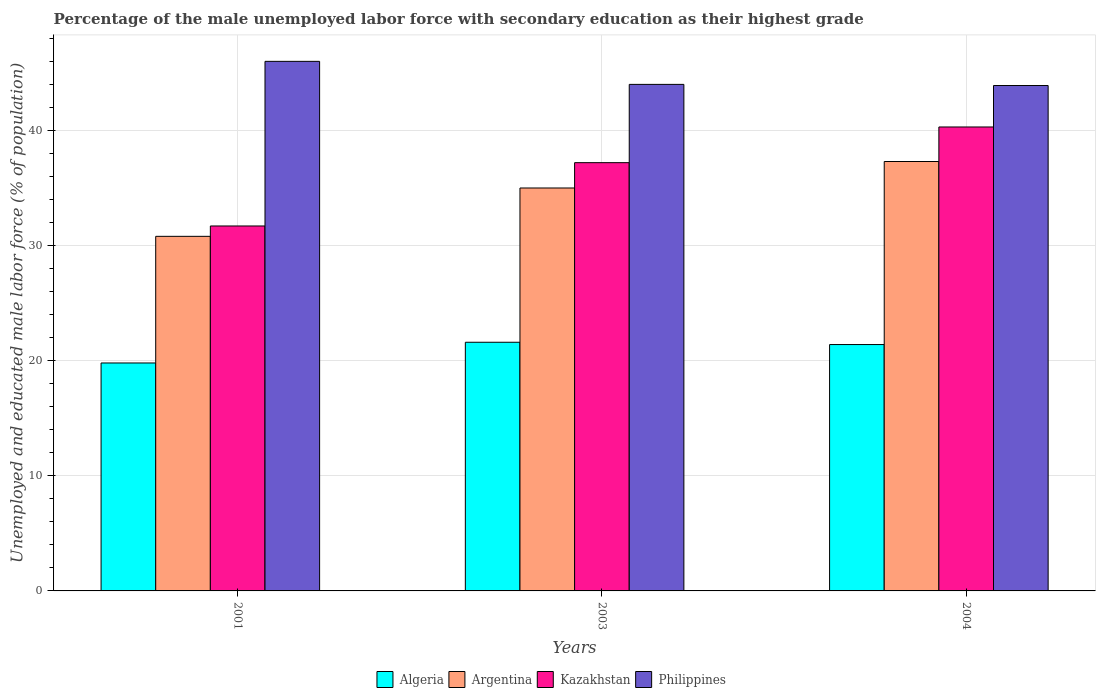How many different coloured bars are there?
Make the answer very short. 4. How many groups of bars are there?
Give a very brief answer. 3. Are the number of bars on each tick of the X-axis equal?
Your answer should be compact. Yes. How many bars are there on the 1st tick from the left?
Your response must be concise. 4. How many bars are there on the 3rd tick from the right?
Offer a terse response. 4. What is the percentage of the unemployed male labor force with secondary education in Kazakhstan in 2004?
Give a very brief answer. 40.3. Across all years, what is the maximum percentage of the unemployed male labor force with secondary education in Philippines?
Your answer should be compact. 46. Across all years, what is the minimum percentage of the unemployed male labor force with secondary education in Philippines?
Provide a succinct answer. 43.9. In which year was the percentage of the unemployed male labor force with secondary education in Kazakhstan maximum?
Offer a very short reply. 2004. What is the total percentage of the unemployed male labor force with secondary education in Kazakhstan in the graph?
Ensure brevity in your answer.  109.2. What is the difference between the percentage of the unemployed male labor force with secondary education in Argentina in 2001 and that in 2003?
Your response must be concise. -4.2. What is the difference between the percentage of the unemployed male labor force with secondary education in Kazakhstan in 2003 and the percentage of the unemployed male labor force with secondary education in Algeria in 2004?
Keep it short and to the point. 15.8. What is the average percentage of the unemployed male labor force with secondary education in Algeria per year?
Keep it short and to the point. 20.93. In the year 2004, what is the difference between the percentage of the unemployed male labor force with secondary education in Algeria and percentage of the unemployed male labor force with secondary education in Philippines?
Your answer should be very brief. -22.5. In how many years, is the percentage of the unemployed male labor force with secondary education in Philippines greater than 20 %?
Give a very brief answer. 3. What is the ratio of the percentage of the unemployed male labor force with secondary education in Kazakhstan in 2003 to that in 2004?
Keep it short and to the point. 0.92. Is the percentage of the unemployed male labor force with secondary education in Philippines in 2003 less than that in 2004?
Provide a succinct answer. No. Is the difference between the percentage of the unemployed male labor force with secondary education in Algeria in 2001 and 2003 greater than the difference between the percentage of the unemployed male labor force with secondary education in Philippines in 2001 and 2003?
Your answer should be very brief. No. What is the difference between the highest and the second highest percentage of the unemployed male labor force with secondary education in Kazakhstan?
Offer a very short reply. 3.1. What is the difference between the highest and the lowest percentage of the unemployed male labor force with secondary education in Philippines?
Keep it short and to the point. 2.1. Is it the case that in every year, the sum of the percentage of the unemployed male labor force with secondary education in Philippines and percentage of the unemployed male labor force with secondary education in Kazakhstan is greater than the sum of percentage of the unemployed male labor force with secondary education in Argentina and percentage of the unemployed male labor force with secondary education in Algeria?
Provide a short and direct response. No. What does the 3rd bar from the left in 2003 represents?
Your answer should be very brief. Kazakhstan. What does the 4th bar from the right in 2001 represents?
Your answer should be compact. Algeria. Is it the case that in every year, the sum of the percentage of the unemployed male labor force with secondary education in Argentina and percentage of the unemployed male labor force with secondary education in Algeria is greater than the percentage of the unemployed male labor force with secondary education in Philippines?
Provide a succinct answer. Yes. What is the difference between two consecutive major ticks on the Y-axis?
Your response must be concise. 10. Are the values on the major ticks of Y-axis written in scientific E-notation?
Keep it short and to the point. No. Does the graph contain any zero values?
Your response must be concise. No. What is the title of the graph?
Provide a succinct answer. Percentage of the male unemployed labor force with secondary education as their highest grade. Does "Lesotho" appear as one of the legend labels in the graph?
Make the answer very short. No. What is the label or title of the Y-axis?
Your answer should be very brief. Unemployed and educated male labor force (% of population). What is the Unemployed and educated male labor force (% of population) in Algeria in 2001?
Provide a short and direct response. 19.8. What is the Unemployed and educated male labor force (% of population) of Argentina in 2001?
Provide a short and direct response. 30.8. What is the Unemployed and educated male labor force (% of population) in Kazakhstan in 2001?
Your answer should be very brief. 31.7. What is the Unemployed and educated male labor force (% of population) in Philippines in 2001?
Give a very brief answer. 46. What is the Unemployed and educated male labor force (% of population) in Algeria in 2003?
Your answer should be compact. 21.6. What is the Unemployed and educated male labor force (% of population) of Kazakhstan in 2003?
Offer a very short reply. 37.2. What is the Unemployed and educated male labor force (% of population) in Algeria in 2004?
Offer a very short reply. 21.4. What is the Unemployed and educated male labor force (% of population) of Argentina in 2004?
Provide a succinct answer. 37.3. What is the Unemployed and educated male labor force (% of population) in Kazakhstan in 2004?
Keep it short and to the point. 40.3. What is the Unemployed and educated male labor force (% of population) of Philippines in 2004?
Make the answer very short. 43.9. Across all years, what is the maximum Unemployed and educated male labor force (% of population) in Algeria?
Your answer should be compact. 21.6. Across all years, what is the maximum Unemployed and educated male labor force (% of population) of Argentina?
Make the answer very short. 37.3. Across all years, what is the maximum Unemployed and educated male labor force (% of population) in Kazakhstan?
Give a very brief answer. 40.3. Across all years, what is the minimum Unemployed and educated male labor force (% of population) in Algeria?
Your response must be concise. 19.8. Across all years, what is the minimum Unemployed and educated male labor force (% of population) in Argentina?
Offer a terse response. 30.8. Across all years, what is the minimum Unemployed and educated male labor force (% of population) of Kazakhstan?
Make the answer very short. 31.7. Across all years, what is the minimum Unemployed and educated male labor force (% of population) of Philippines?
Your answer should be very brief. 43.9. What is the total Unemployed and educated male labor force (% of population) in Algeria in the graph?
Keep it short and to the point. 62.8. What is the total Unemployed and educated male labor force (% of population) of Argentina in the graph?
Your answer should be compact. 103.1. What is the total Unemployed and educated male labor force (% of population) of Kazakhstan in the graph?
Provide a succinct answer. 109.2. What is the total Unemployed and educated male labor force (% of population) of Philippines in the graph?
Provide a short and direct response. 133.9. What is the difference between the Unemployed and educated male labor force (% of population) of Algeria in 2001 and that in 2003?
Offer a very short reply. -1.8. What is the difference between the Unemployed and educated male labor force (% of population) in Argentina in 2001 and that in 2003?
Offer a very short reply. -4.2. What is the difference between the Unemployed and educated male labor force (% of population) in Philippines in 2001 and that in 2003?
Make the answer very short. 2. What is the difference between the Unemployed and educated male labor force (% of population) in Argentina in 2001 and that in 2004?
Offer a very short reply. -6.5. What is the difference between the Unemployed and educated male labor force (% of population) in Kazakhstan in 2001 and that in 2004?
Provide a short and direct response. -8.6. What is the difference between the Unemployed and educated male labor force (% of population) in Algeria in 2003 and that in 2004?
Give a very brief answer. 0.2. What is the difference between the Unemployed and educated male labor force (% of population) in Philippines in 2003 and that in 2004?
Your response must be concise. 0.1. What is the difference between the Unemployed and educated male labor force (% of population) in Algeria in 2001 and the Unemployed and educated male labor force (% of population) in Argentina in 2003?
Give a very brief answer. -15.2. What is the difference between the Unemployed and educated male labor force (% of population) of Algeria in 2001 and the Unemployed and educated male labor force (% of population) of Kazakhstan in 2003?
Ensure brevity in your answer.  -17.4. What is the difference between the Unemployed and educated male labor force (% of population) of Algeria in 2001 and the Unemployed and educated male labor force (% of population) of Philippines in 2003?
Keep it short and to the point. -24.2. What is the difference between the Unemployed and educated male labor force (% of population) of Algeria in 2001 and the Unemployed and educated male labor force (% of population) of Argentina in 2004?
Keep it short and to the point. -17.5. What is the difference between the Unemployed and educated male labor force (% of population) of Algeria in 2001 and the Unemployed and educated male labor force (% of population) of Kazakhstan in 2004?
Offer a very short reply. -20.5. What is the difference between the Unemployed and educated male labor force (% of population) of Algeria in 2001 and the Unemployed and educated male labor force (% of population) of Philippines in 2004?
Give a very brief answer. -24.1. What is the difference between the Unemployed and educated male labor force (% of population) in Argentina in 2001 and the Unemployed and educated male labor force (% of population) in Kazakhstan in 2004?
Your answer should be compact. -9.5. What is the difference between the Unemployed and educated male labor force (% of population) in Algeria in 2003 and the Unemployed and educated male labor force (% of population) in Argentina in 2004?
Your response must be concise. -15.7. What is the difference between the Unemployed and educated male labor force (% of population) of Algeria in 2003 and the Unemployed and educated male labor force (% of population) of Kazakhstan in 2004?
Your answer should be very brief. -18.7. What is the difference between the Unemployed and educated male labor force (% of population) of Algeria in 2003 and the Unemployed and educated male labor force (% of population) of Philippines in 2004?
Offer a terse response. -22.3. What is the difference between the Unemployed and educated male labor force (% of population) in Argentina in 2003 and the Unemployed and educated male labor force (% of population) in Kazakhstan in 2004?
Make the answer very short. -5.3. What is the difference between the Unemployed and educated male labor force (% of population) of Argentina in 2003 and the Unemployed and educated male labor force (% of population) of Philippines in 2004?
Provide a short and direct response. -8.9. What is the average Unemployed and educated male labor force (% of population) of Algeria per year?
Your answer should be compact. 20.93. What is the average Unemployed and educated male labor force (% of population) of Argentina per year?
Offer a very short reply. 34.37. What is the average Unemployed and educated male labor force (% of population) of Kazakhstan per year?
Give a very brief answer. 36.4. What is the average Unemployed and educated male labor force (% of population) of Philippines per year?
Your response must be concise. 44.63. In the year 2001, what is the difference between the Unemployed and educated male labor force (% of population) of Algeria and Unemployed and educated male labor force (% of population) of Kazakhstan?
Provide a short and direct response. -11.9. In the year 2001, what is the difference between the Unemployed and educated male labor force (% of population) of Algeria and Unemployed and educated male labor force (% of population) of Philippines?
Offer a terse response. -26.2. In the year 2001, what is the difference between the Unemployed and educated male labor force (% of population) in Argentina and Unemployed and educated male labor force (% of population) in Kazakhstan?
Your response must be concise. -0.9. In the year 2001, what is the difference between the Unemployed and educated male labor force (% of population) in Argentina and Unemployed and educated male labor force (% of population) in Philippines?
Offer a very short reply. -15.2. In the year 2001, what is the difference between the Unemployed and educated male labor force (% of population) of Kazakhstan and Unemployed and educated male labor force (% of population) of Philippines?
Your answer should be very brief. -14.3. In the year 2003, what is the difference between the Unemployed and educated male labor force (% of population) in Algeria and Unemployed and educated male labor force (% of population) in Argentina?
Provide a succinct answer. -13.4. In the year 2003, what is the difference between the Unemployed and educated male labor force (% of population) of Algeria and Unemployed and educated male labor force (% of population) of Kazakhstan?
Keep it short and to the point. -15.6. In the year 2003, what is the difference between the Unemployed and educated male labor force (% of population) in Algeria and Unemployed and educated male labor force (% of population) in Philippines?
Your answer should be compact. -22.4. In the year 2004, what is the difference between the Unemployed and educated male labor force (% of population) in Algeria and Unemployed and educated male labor force (% of population) in Argentina?
Keep it short and to the point. -15.9. In the year 2004, what is the difference between the Unemployed and educated male labor force (% of population) of Algeria and Unemployed and educated male labor force (% of population) of Kazakhstan?
Offer a very short reply. -18.9. In the year 2004, what is the difference between the Unemployed and educated male labor force (% of population) of Algeria and Unemployed and educated male labor force (% of population) of Philippines?
Provide a succinct answer. -22.5. What is the ratio of the Unemployed and educated male labor force (% of population) of Algeria in 2001 to that in 2003?
Offer a very short reply. 0.92. What is the ratio of the Unemployed and educated male labor force (% of population) of Argentina in 2001 to that in 2003?
Offer a very short reply. 0.88. What is the ratio of the Unemployed and educated male labor force (% of population) of Kazakhstan in 2001 to that in 2003?
Your answer should be very brief. 0.85. What is the ratio of the Unemployed and educated male labor force (% of population) in Philippines in 2001 to that in 2003?
Give a very brief answer. 1.05. What is the ratio of the Unemployed and educated male labor force (% of population) of Algeria in 2001 to that in 2004?
Give a very brief answer. 0.93. What is the ratio of the Unemployed and educated male labor force (% of population) of Argentina in 2001 to that in 2004?
Offer a terse response. 0.83. What is the ratio of the Unemployed and educated male labor force (% of population) of Kazakhstan in 2001 to that in 2004?
Keep it short and to the point. 0.79. What is the ratio of the Unemployed and educated male labor force (% of population) in Philippines in 2001 to that in 2004?
Provide a succinct answer. 1.05. What is the ratio of the Unemployed and educated male labor force (% of population) in Algeria in 2003 to that in 2004?
Your answer should be compact. 1.01. What is the ratio of the Unemployed and educated male labor force (% of population) in Argentina in 2003 to that in 2004?
Make the answer very short. 0.94. What is the ratio of the Unemployed and educated male labor force (% of population) of Kazakhstan in 2003 to that in 2004?
Provide a succinct answer. 0.92. What is the difference between the highest and the second highest Unemployed and educated male labor force (% of population) of Algeria?
Make the answer very short. 0.2. What is the difference between the highest and the second highest Unemployed and educated male labor force (% of population) of Argentina?
Keep it short and to the point. 2.3. What is the difference between the highest and the second highest Unemployed and educated male labor force (% of population) of Kazakhstan?
Your answer should be very brief. 3.1. What is the difference between the highest and the second highest Unemployed and educated male labor force (% of population) of Philippines?
Provide a succinct answer. 2. What is the difference between the highest and the lowest Unemployed and educated male labor force (% of population) of Argentina?
Offer a terse response. 6.5. What is the difference between the highest and the lowest Unemployed and educated male labor force (% of population) in Kazakhstan?
Provide a succinct answer. 8.6. What is the difference between the highest and the lowest Unemployed and educated male labor force (% of population) in Philippines?
Provide a succinct answer. 2.1. 